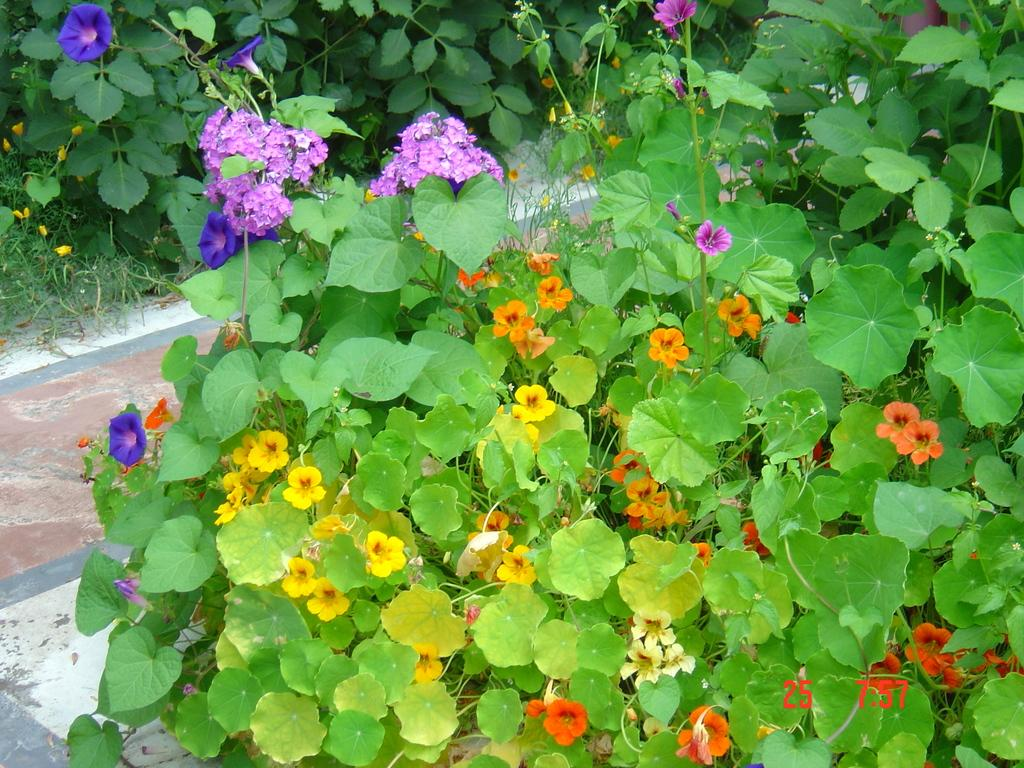What type of vegetation is present in the image? There are green color leaves and flowers in the image. Can you describe the flowers in the image? Unfortunately, the facts provided do not give specific details about the flowers. Are there any other elements in the image besides the leaves and flowers? The facts provided do not mention any other elements in the image. Is there a river flowing through the image? There is no mention of a river in the provided facts, so it cannot be determined if one is present in the image. What grade of paper is used for the flowers in the image? The facts provided do not mention any paper or grades, and the image shows real flowers, not paper ones. 